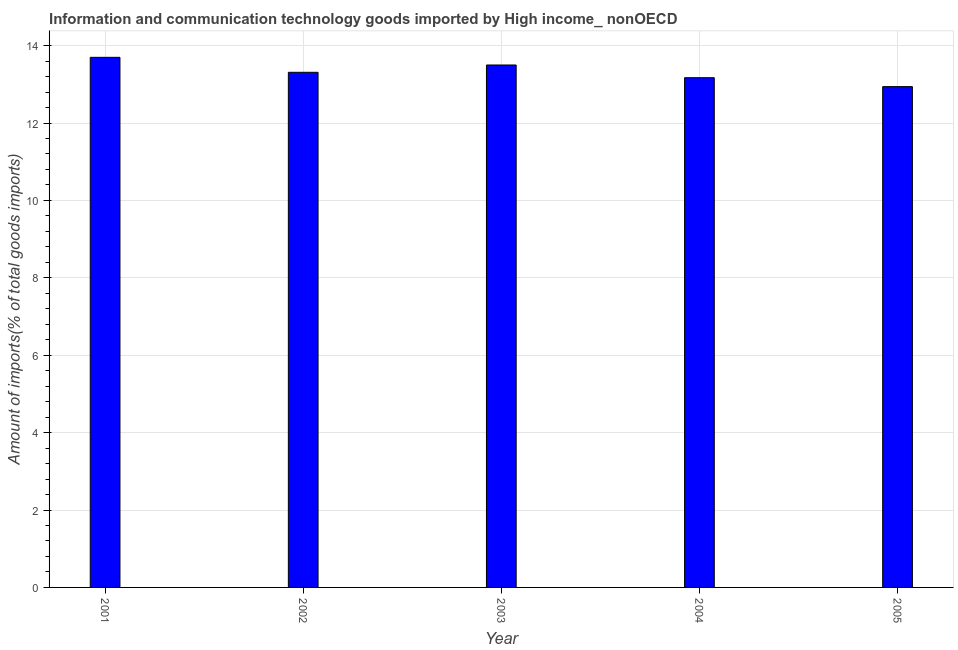Does the graph contain grids?
Keep it short and to the point. Yes. What is the title of the graph?
Offer a very short reply. Information and communication technology goods imported by High income_ nonOECD. What is the label or title of the Y-axis?
Your response must be concise. Amount of imports(% of total goods imports). What is the amount of ict goods imports in 2005?
Give a very brief answer. 12.94. Across all years, what is the maximum amount of ict goods imports?
Provide a succinct answer. 13.7. Across all years, what is the minimum amount of ict goods imports?
Your response must be concise. 12.94. In which year was the amount of ict goods imports maximum?
Offer a very short reply. 2001. In which year was the amount of ict goods imports minimum?
Offer a very short reply. 2005. What is the sum of the amount of ict goods imports?
Your answer should be very brief. 66.62. What is the difference between the amount of ict goods imports in 2002 and 2004?
Ensure brevity in your answer.  0.14. What is the average amount of ict goods imports per year?
Ensure brevity in your answer.  13.32. What is the median amount of ict goods imports?
Your response must be concise. 13.31. Do a majority of the years between 2001 and 2004 (inclusive) have amount of ict goods imports greater than 3.2 %?
Provide a succinct answer. Yes. What is the ratio of the amount of ict goods imports in 2002 to that in 2005?
Keep it short and to the point. 1.03. Is the amount of ict goods imports in 2003 less than that in 2004?
Provide a succinct answer. No. Is the difference between the amount of ict goods imports in 2001 and 2004 greater than the difference between any two years?
Your response must be concise. No. What is the difference between the highest and the second highest amount of ict goods imports?
Provide a succinct answer. 0.2. Is the sum of the amount of ict goods imports in 2001 and 2004 greater than the maximum amount of ict goods imports across all years?
Ensure brevity in your answer.  Yes. What is the difference between the highest and the lowest amount of ict goods imports?
Your answer should be compact. 0.76. In how many years, is the amount of ict goods imports greater than the average amount of ict goods imports taken over all years?
Make the answer very short. 2. How many bars are there?
Your answer should be compact. 5. How many years are there in the graph?
Your response must be concise. 5. What is the difference between two consecutive major ticks on the Y-axis?
Your answer should be very brief. 2. What is the Amount of imports(% of total goods imports) in 2001?
Offer a very short reply. 13.7. What is the Amount of imports(% of total goods imports) of 2002?
Offer a very short reply. 13.31. What is the Amount of imports(% of total goods imports) in 2003?
Your response must be concise. 13.5. What is the Amount of imports(% of total goods imports) of 2004?
Ensure brevity in your answer.  13.17. What is the Amount of imports(% of total goods imports) of 2005?
Your response must be concise. 12.94. What is the difference between the Amount of imports(% of total goods imports) in 2001 and 2002?
Provide a short and direct response. 0.39. What is the difference between the Amount of imports(% of total goods imports) in 2001 and 2003?
Your answer should be compact. 0.2. What is the difference between the Amount of imports(% of total goods imports) in 2001 and 2004?
Your answer should be very brief. 0.53. What is the difference between the Amount of imports(% of total goods imports) in 2001 and 2005?
Offer a very short reply. 0.76. What is the difference between the Amount of imports(% of total goods imports) in 2002 and 2003?
Your answer should be compact. -0.19. What is the difference between the Amount of imports(% of total goods imports) in 2002 and 2004?
Offer a terse response. 0.14. What is the difference between the Amount of imports(% of total goods imports) in 2002 and 2005?
Your answer should be compact. 0.37. What is the difference between the Amount of imports(% of total goods imports) in 2003 and 2004?
Provide a succinct answer. 0.33. What is the difference between the Amount of imports(% of total goods imports) in 2003 and 2005?
Offer a very short reply. 0.56. What is the difference between the Amount of imports(% of total goods imports) in 2004 and 2005?
Offer a very short reply. 0.23. What is the ratio of the Amount of imports(% of total goods imports) in 2001 to that in 2003?
Provide a succinct answer. 1.01. What is the ratio of the Amount of imports(% of total goods imports) in 2001 to that in 2005?
Keep it short and to the point. 1.06. What is the ratio of the Amount of imports(% of total goods imports) in 2002 to that in 2003?
Your response must be concise. 0.99. What is the ratio of the Amount of imports(% of total goods imports) in 2002 to that in 2005?
Keep it short and to the point. 1.03. What is the ratio of the Amount of imports(% of total goods imports) in 2003 to that in 2004?
Ensure brevity in your answer.  1.02. What is the ratio of the Amount of imports(% of total goods imports) in 2003 to that in 2005?
Provide a succinct answer. 1.04. What is the ratio of the Amount of imports(% of total goods imports) in 2004 to that in 2005?
Provide a short and direct response. 1.02. 